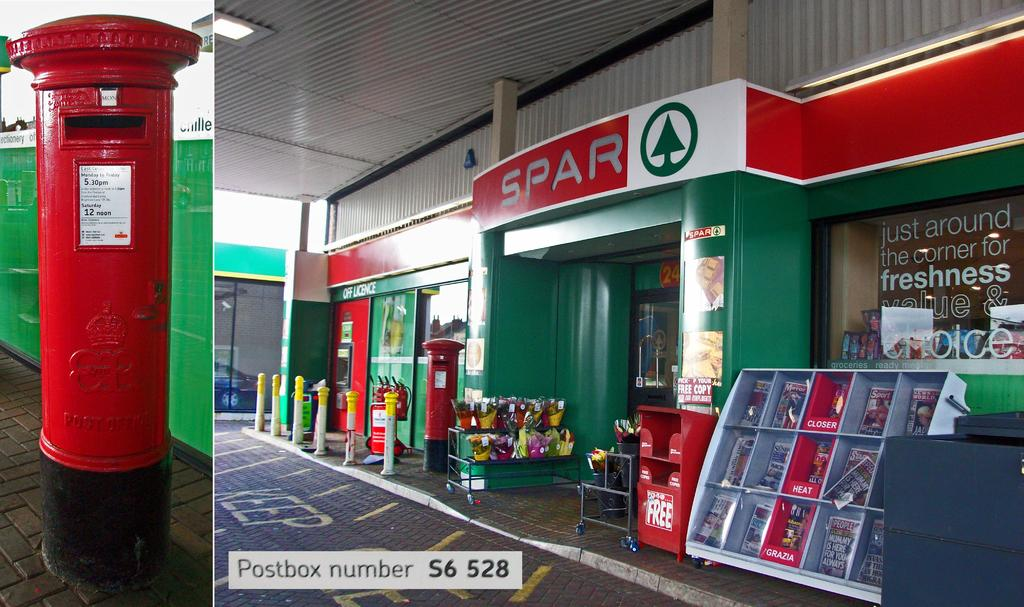Provide a one-sentence caption for the provided image. The green and red store front for Spar with bollards and items outside. 